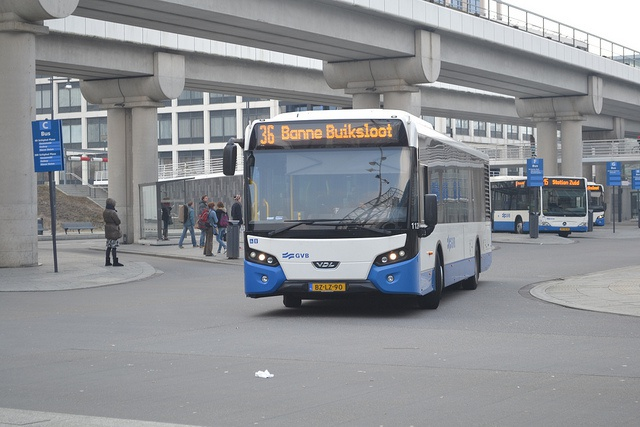Describe the objects in this image and their specific colors. I can see bus in gray, darkgray, and lightgray tones, bus in gray, lightgray, darkblue, and black tones, people in gray and black tones, bus in gray, darkgray, darkblue, and lightgray tones, and people in gray, black, and blue tones in this image. 